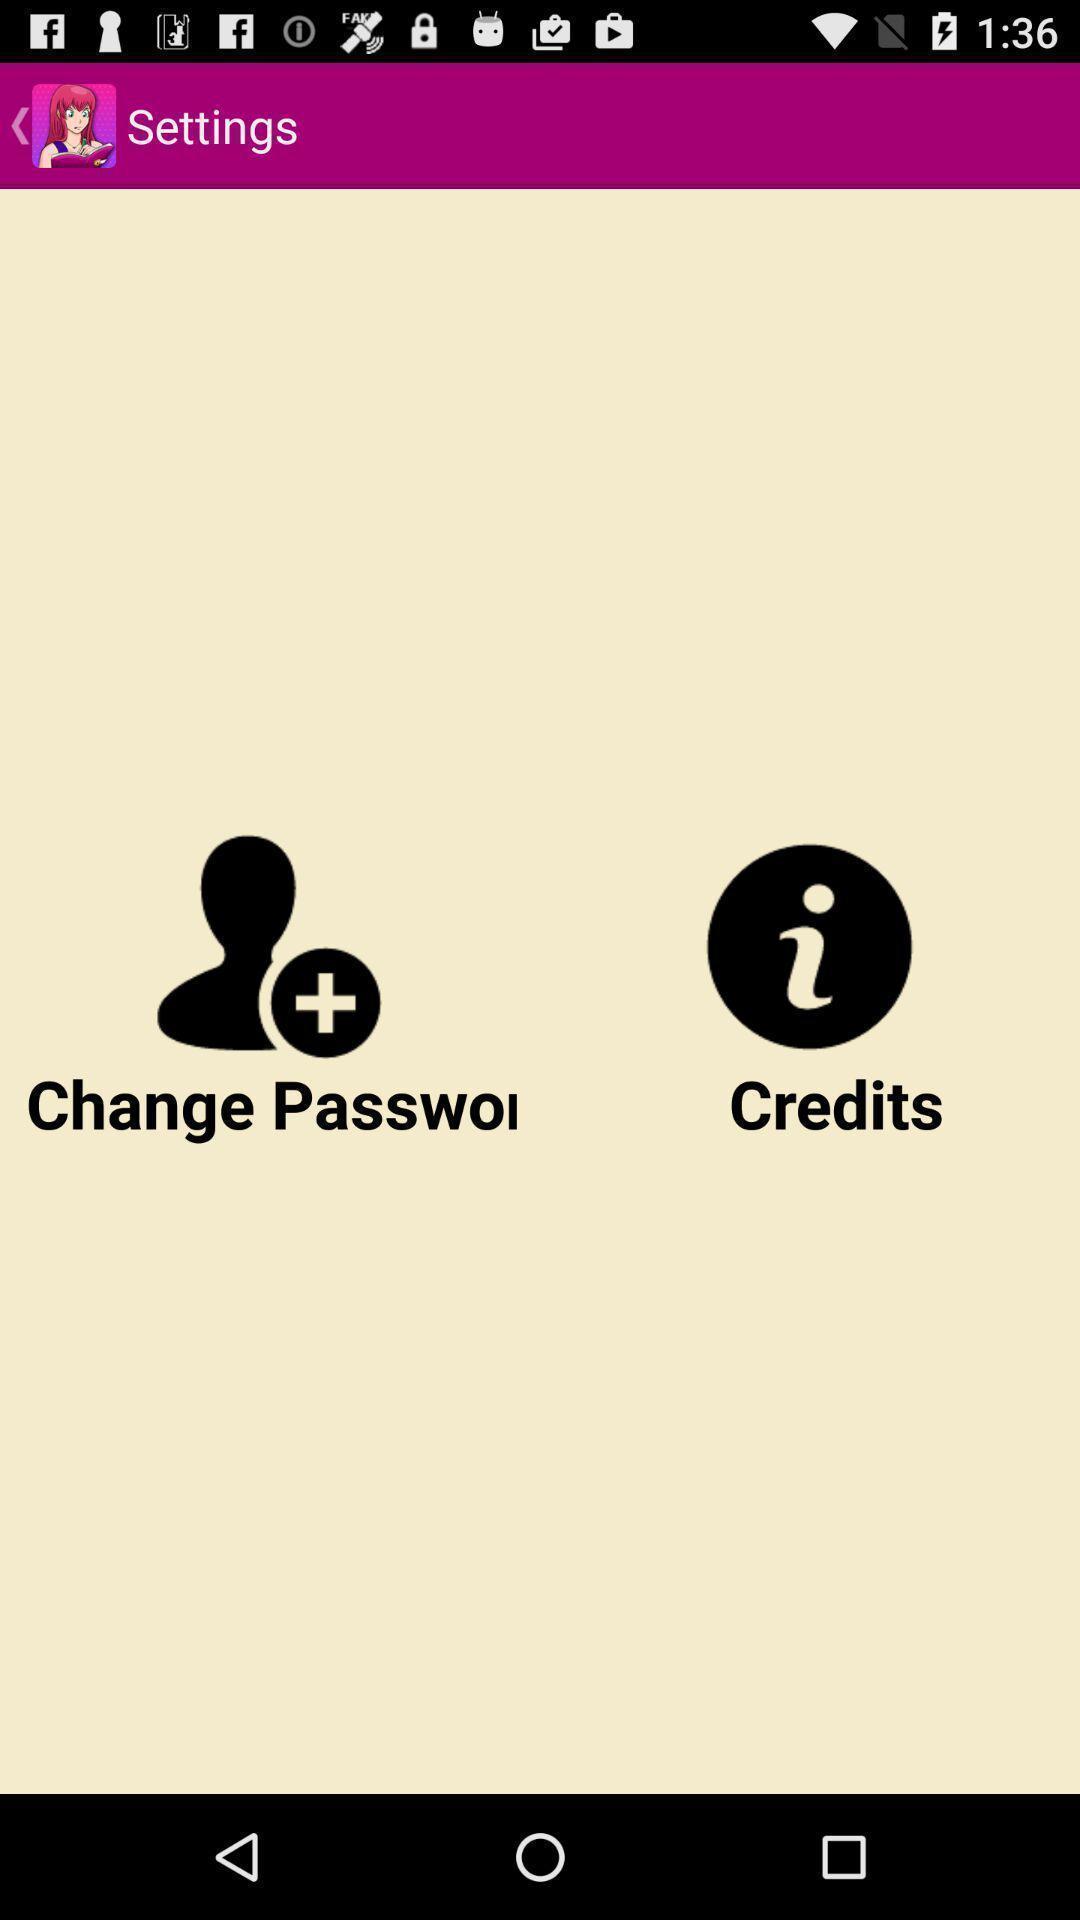Summarize the main components in this picture. Settings page. 